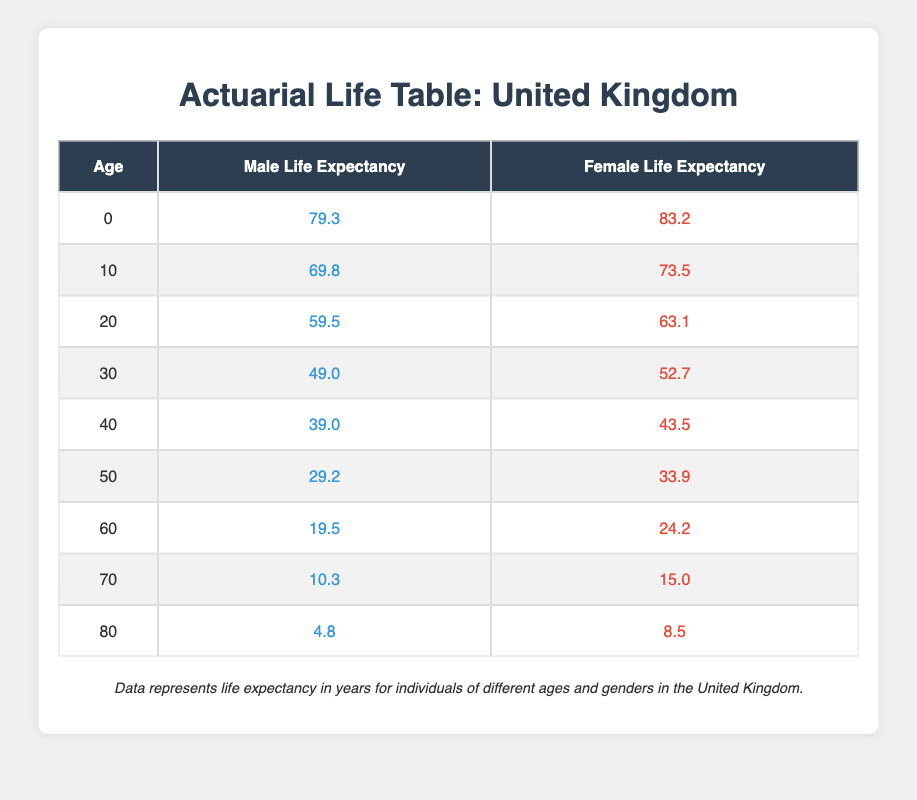What is the life expectancy of a 60-year-old male in the UK? From the table, the life expectancy for a male at age 60 is provided directly as 19.5 years.
Answer: 19.5 What is the life expectancy difference between a 70-year-old male and a 70-year-old female? The life expectancy for a 70-year-old male is 10.3 years and for a female it is 15.0 years. The difference is 15.0 - 10.3 = 4.7 years.
Answer: 4.7 Is the life expectancy of a 40-year-old female higher than that of a 30-year-old male? The life expectancy for a 40-year-old female is 43.5 years, while for a 30-year-old male it is 49.0 years. Since 43.5 is less than 49.0, the statement is false.
Answer: No What is the combined life expectancy of a 20-year-old male and a 40-year-old female? The life expectancy for a 20-year-old male is 59.5 years and for a 40-year-old female is 43.5 years. Summing these gives 59.5 + 43.5 = 103.0 years.
Answer: 103.0 How many years longer can a female at age 80 expect to live compared to a male at the same age? The life expectancy for an 80-year-old female is 8.5 years and for an 80-year-old male is 4.8 years. The difference is 8.5 - 4.8 = 3.7 years.
Answer: 3.7 What age has the highest life expectancy for males in this table? Reviewing the data, the highest life expectancy for males occurs at age 0 with a life expectancy of 79.3 years, as no other age exceeds this figure.
Answer: 0 Are females of all ages consistently expected to live longer than males according to this table? By checking the life expectancy values, females consistently have higher values than males across all ages listed, indicating that they are expected to live longer in each category.
Answer: Yes What is the average life expectancy of females across all ages provided in this table? First, sum the life expectancy values for females: 83.2 + 73.5 + 63.1 + 52.7 + 43.5 + 33.9 + 24.2 + 15.0 + 8.5 = 393.1 years. Next, divide by the number of age groups (9): 393.1 / 9 = 43.68 years, which rounds to 43.7 years for the average.
Answer: 43.7 